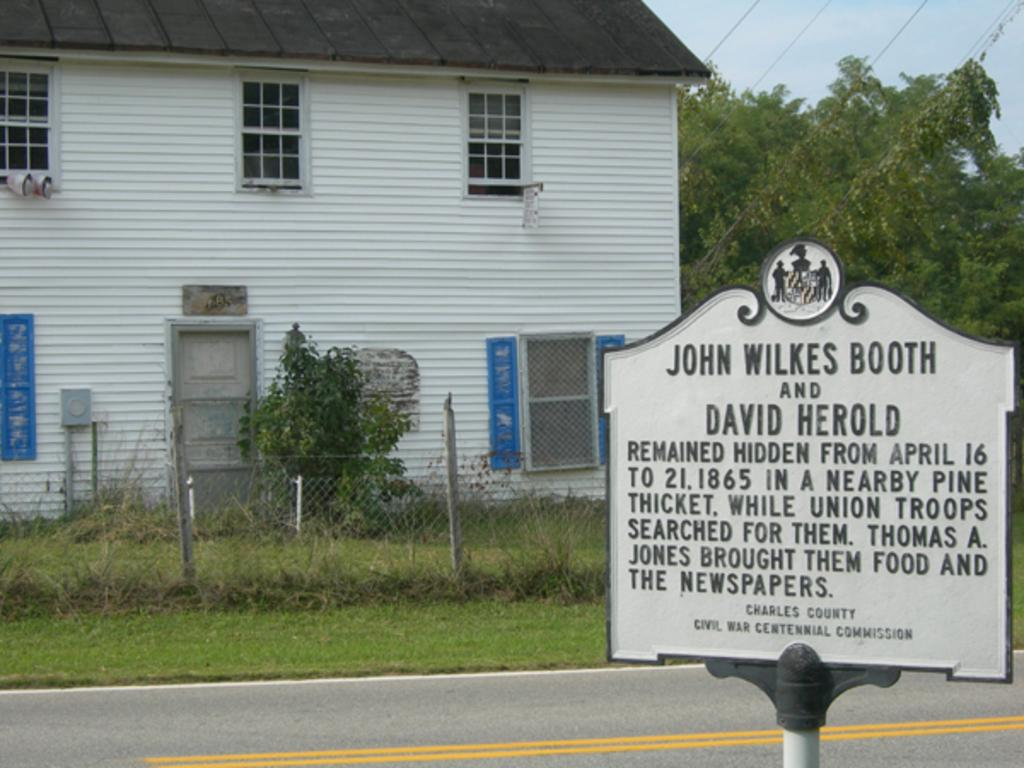What is the main structure in the center of the image? There is a building in the center of the image. What type of vegetation can be seen on the right side of the image? There are trees on the right side of the image. What is located at the bottom of the image? There is a board and a fence at the bottom of the image. What type of ground cover is visible in the image? There is grass visible in the image. Can you see the maid holding a toy in the image? There is no maid or toy present in the image. Who is the mother in the image? There is no mother or any people present in the image. 